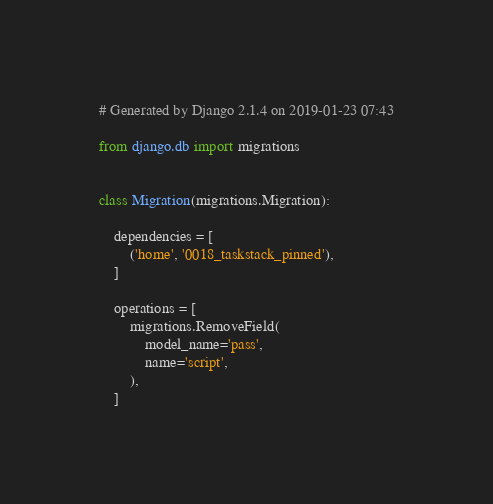<code> <loc_0><loc_0><loc_500><loc_500><_Python_># Generated by Django 2.1.4 on 2019-01-23 07:43

from django.db import migrations


class Migration(migrations.Migration):

    dependencies = [
        ('home', '0018_taskstack_pinned'),
    ]

    operations = [
        migrations.RemoveField(
            model_name='pass',
            name='script',
        ),
    ]
</code> 